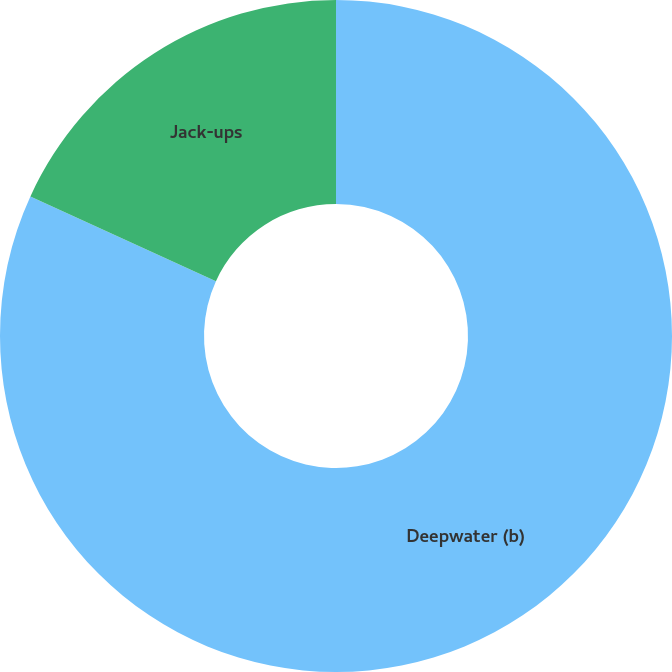Convert chart. <chart><loc_0><loc_0><loc_500><loc_500><pie_chart><fcel>Deepwater (b)<fcel>Jack-ups<nl><fcel>81.82%<fcel>18.18%<nl></chart> 